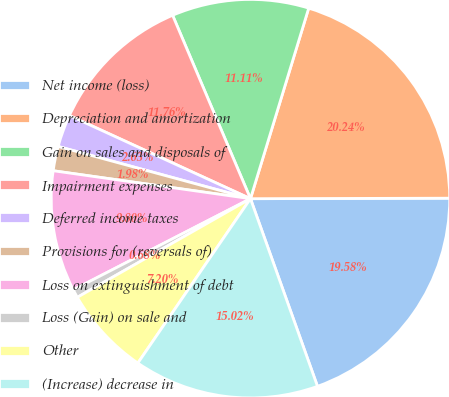Convert chart. <chart><loc_0><loc_0><loc_500><loc_500><pie_chart><fcel>Net income (loss)<fcel>Depreciation and amortization<fcel>Gain on sales and disposals of<fcel>Impairment expenses<fcel>Deferred income taxes<fcel>Provisions for (reversals of)<fcel>Loss on extinguishment of debt<fcel>Loss (Gain) on sale and<fcel>Other<fcel>(Increase) decrease in<nl><fcel>19.58%<fcel>20.24%<fcel>11.11%<fcel>11.76%<fcel>2.63%<fcel>1.98%<fcel>9.8%<fcel>0.68%<fcel>7.2%<fcel>15.02%<nl></chart> 